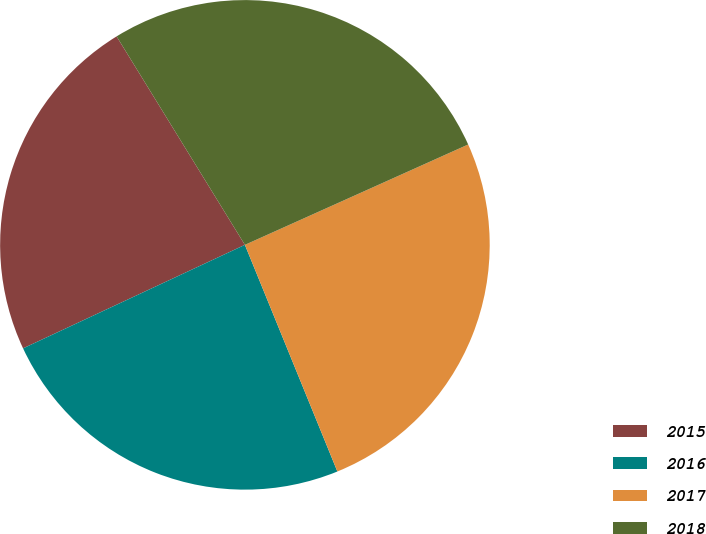Convert chart. <chart><loc_0><loc_0><loc_500><loc_500><pie_chart><fcel>2015<fcel>2016<fcel>2017<fcel>2018<nl><fcel>23.17%<fcel>24.22%<fcel>25.56%<fcel>27.06%<nl></chart> 